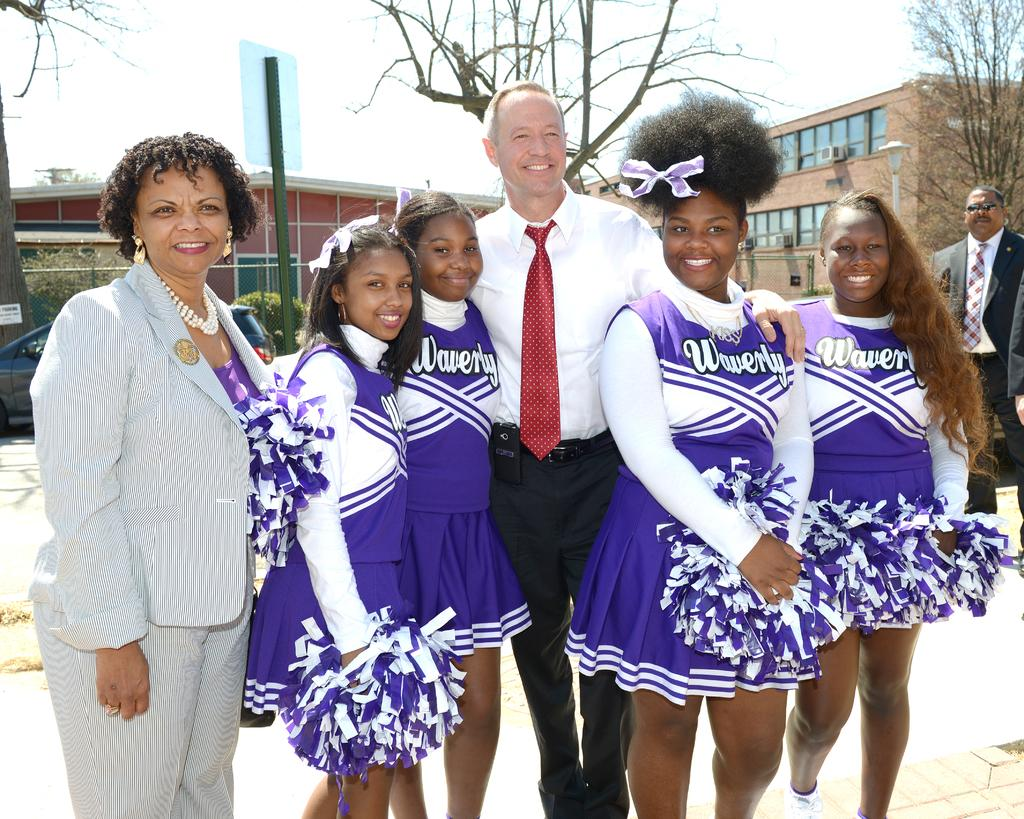<image>
Present a compact description of the photo's key features. a few people posing and the cheerleaders are wearing Waverly jerseys 